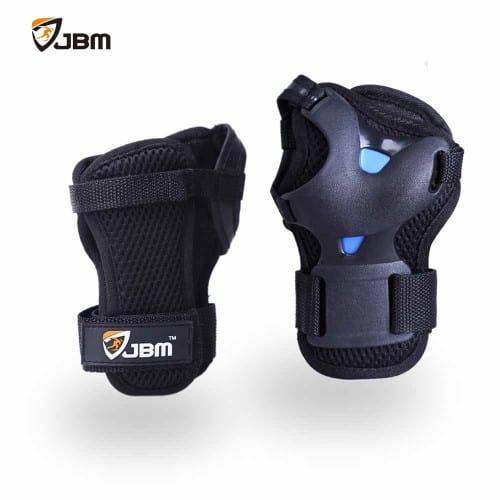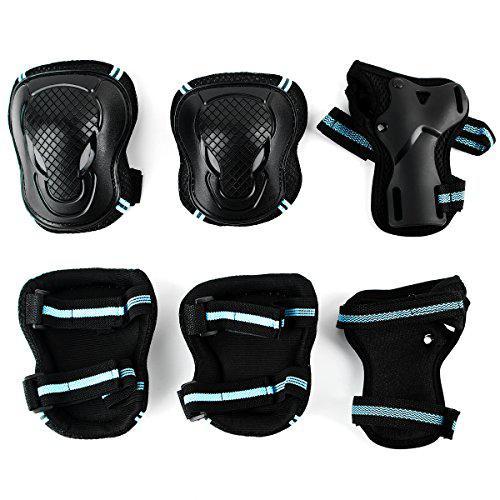The first image is the image on the left, the second image is the image on the right. Examine the images to the left and right. Is the description "There are no more than five knee braces." accurate? Answer yes or no. No. The first image is the image on the left, the second image is the image on the right. Assess this claim about the two images: "An image shows a line of three protective gear items, featuring round perforated pads for the knee and elbow.". Correct or not? Answer yes or no. No. 